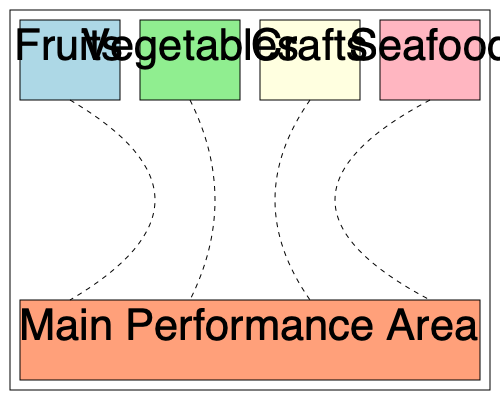In the given floor plan of an immersive theater space inspired by a Filipino marketplace, what is the optimal audience flow pattern to maximize engagement with all sections while ensuring smooth transitions between performance areas? Calculate the total distance covered by an audience member visiting all sections in the optimal order, assuming the theater space is 20 meters wide and 15 meters deep. To determine the optimal audience flow and calculate the total distance covered, we'll follow these steps:

1. Identify the sections:
   - Fruits (top-left)
   - Vegetables (top-middle-left)
   - Crafts (top-middle-right)
   - Seafood (top-right)
   - Main Performance Area (bottom)

2. Determine the optimal flow:
   - Start at the Main Performance Area
   - Visit each section in a circular pattern
   - Return to the Main Performance Area

3. Calculate distances:
   - Theater dimensions: 20m wide x 15m deep
   - Each section is approximately 1/4 of the width: 5m
   - Distance between sections: 5m
   - Distance from sections to Main Performance Area: 7.5m (half the depth)

4. Optimal path:
   Main Performance Area → Fruits → Vegetables → Crafts → Seafood → Main Performance Area

5. Calculate total distance:
   - Main Performance Area to Fruits: 7.5m
   - Fruits to Vegetables: 5m
   - Vegetables to Crafts: 5m
   - Crafts to Seafood: 5m
   - Seafood to Main Performance Area: 7.5m

   Total distance = 7.5m + 5m + 5m + 5m + 7.5m = 30m

This flow pattern ensures that audience members engage with all sections while minimizing backtracking and maintaining a smooth, circular movement throughout the space.
Answer: 30 meters 